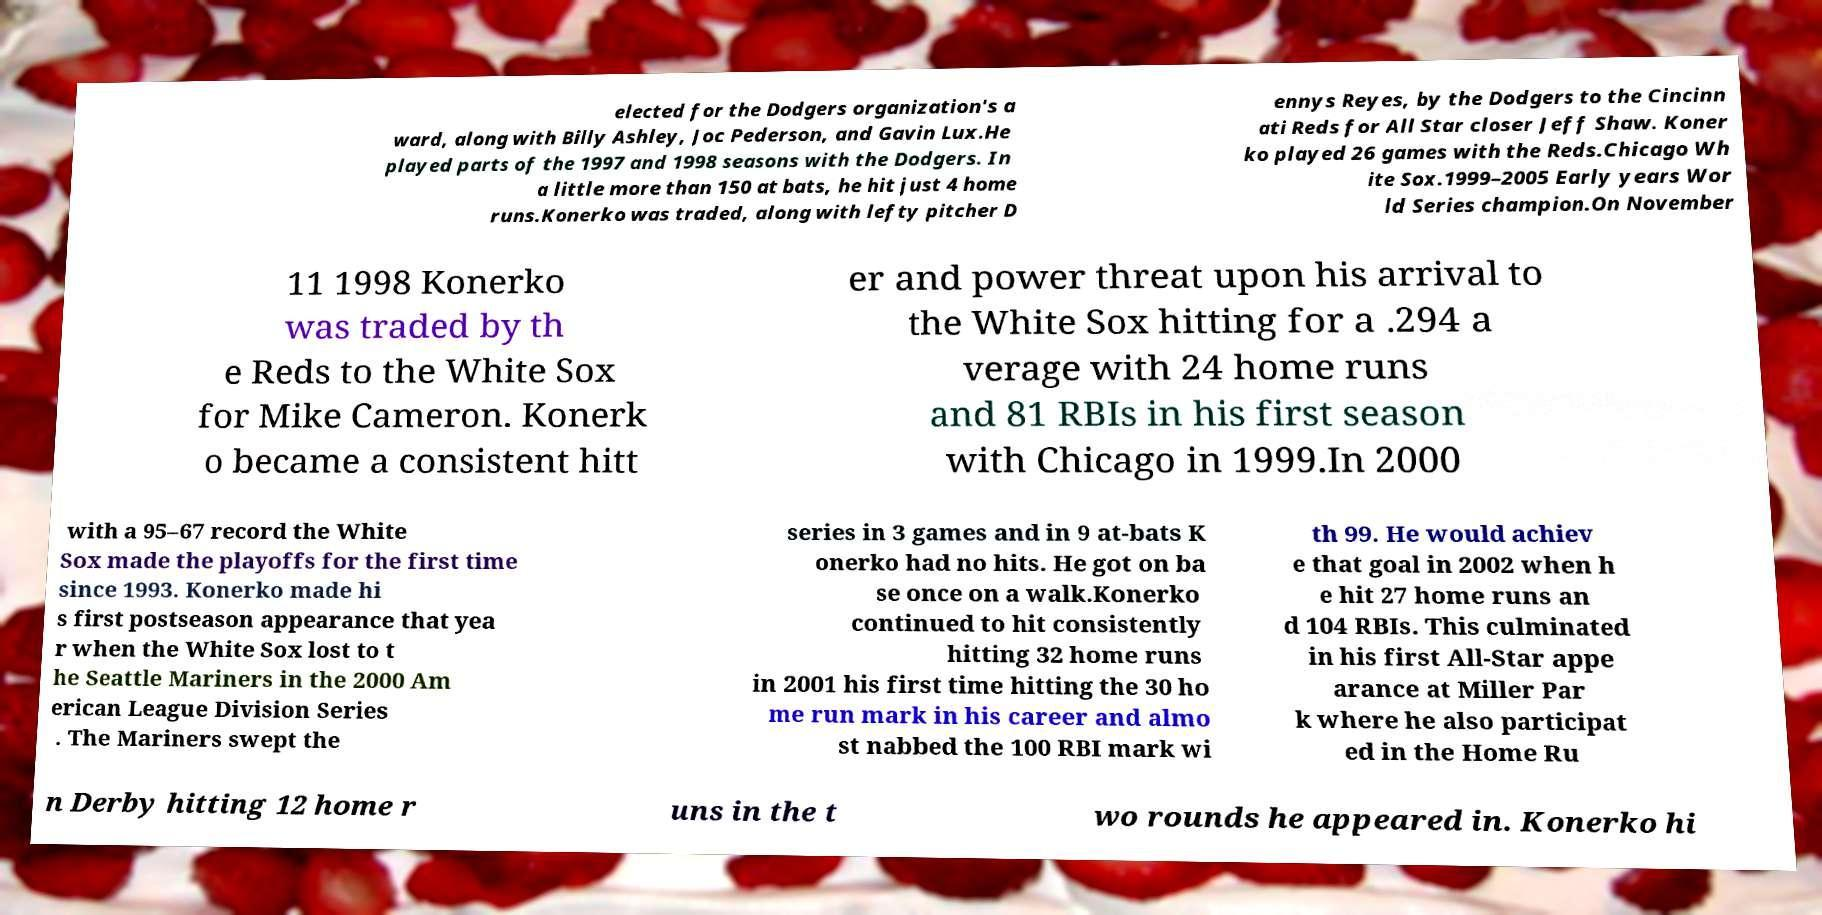Can you accurately transcribe the text from the provided image for me? elected for the Dodgers organization's a ward, along with Billy Ashley, Joc Pederson, and Gavin Lux.He played parts of the 1997 and 1998 seasons with the Dodgers. In a little more than 150 at bats, he hit just 4 home runs.Konerko was traded, along with lefty pitcher D ennys Reyes, by the Dodgers to the Cincinn ati Reds for All Star closer Jeff Shaw. Koner ko played 26 games with the Reds.Chicago Wh ite Sox.1999–2005 Early years Wor ld Series champion.On November 11 1998 Konerko was traded by th e Reds to the White Sox for Mike Cameron. Konerk o became a consistent hitt er and power threat upon his arrival to the White Sox hitting for a .294 a verage with 24 home runs and 81 RBIs in his first season with Chicago in 1999.In 2000 with a 95–67 record the White Sox made the playoffs for the first time since 1993. Konerko made hi s first postseason appearance that yea r when the White Sox lost to t he Seattle Mariners in the 2000 Am erican League Division Series . The Mariners swept the series in 3 games and in 9 at-bats K onerko had no hits. He got on ba se once on a walk.Konerko continued to hit consistently hitting 32 home runs in 2001 his first time hitting the 30 ho me run mark in his career and almo st nabbed the 100 RBI mark wi th 99. He would achiev e that goal in 2002 when h e hit 27 home runs an d 104 RBIs. This culminated in his first All-Star appe arance at Miller Par k where he also participat ed in the Home Ru n Derby hitting 12 home r uns in the t wo rounds he appeared in. Konerko hi 